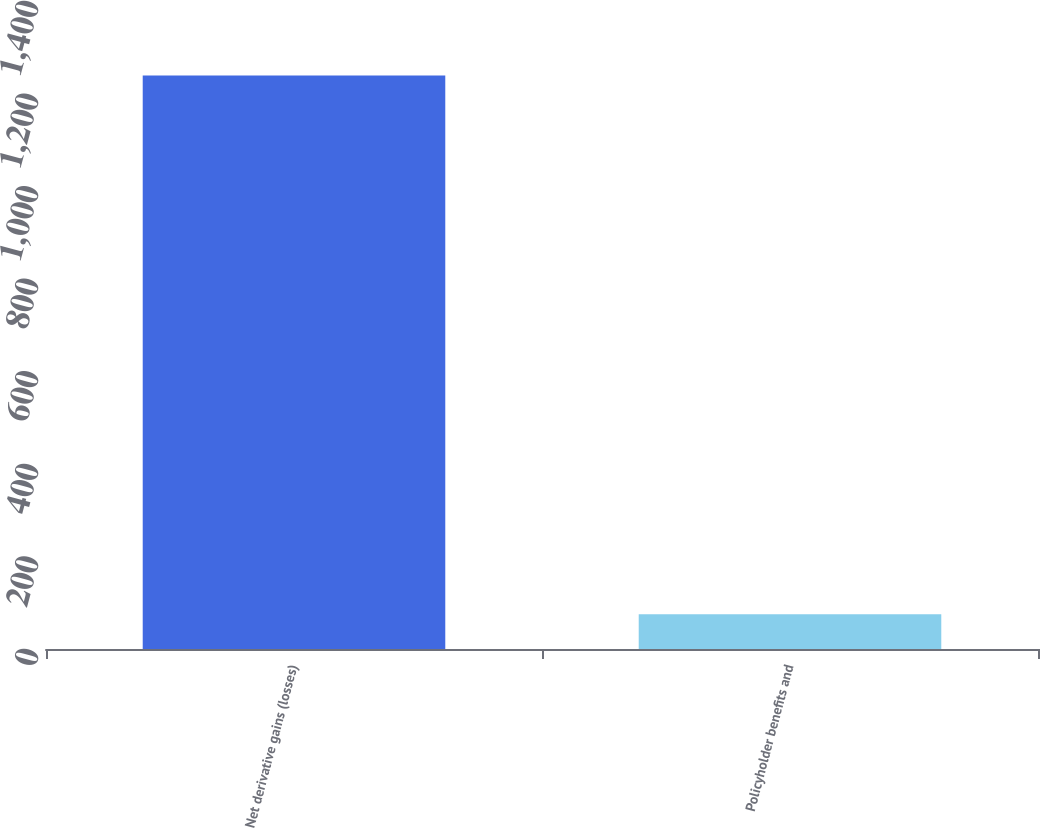<chart> <loc_0><loc_0><loc_500><loc_500><bar_chart><fcel>Net derivative gains (losses)<fcel>Policyholder benefits and<nl><fcel>1239<fcel>75<nl></chart> 